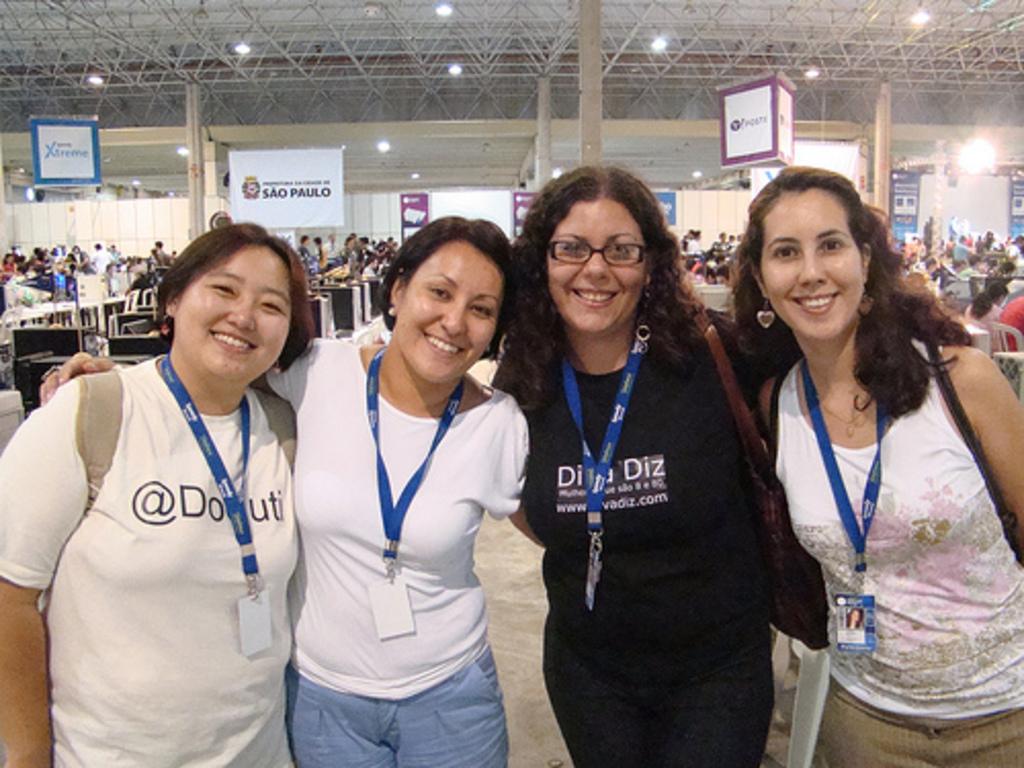What is written after the @ symbol?
Ensure brevity in your answer.  Do. 